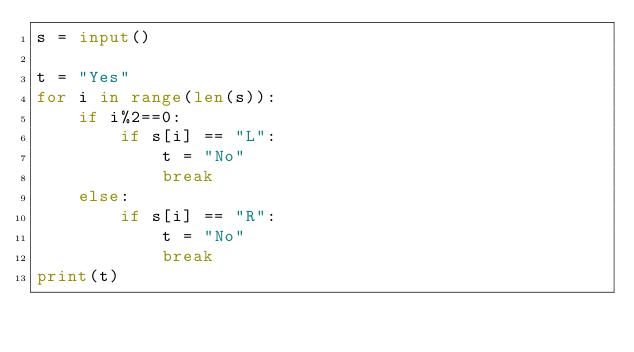Convert code to text. <code><loc_0><loc_0><loc_500><loc_500><_Python_>s = input()

t = "Yes"
for i in range(len(s)):
    if i%2==0:
        if s[i] == "L":
            t = "No"
            break
    else:
        if s[i] == "R":
            t = "No"
            break
print(t)

</code> 